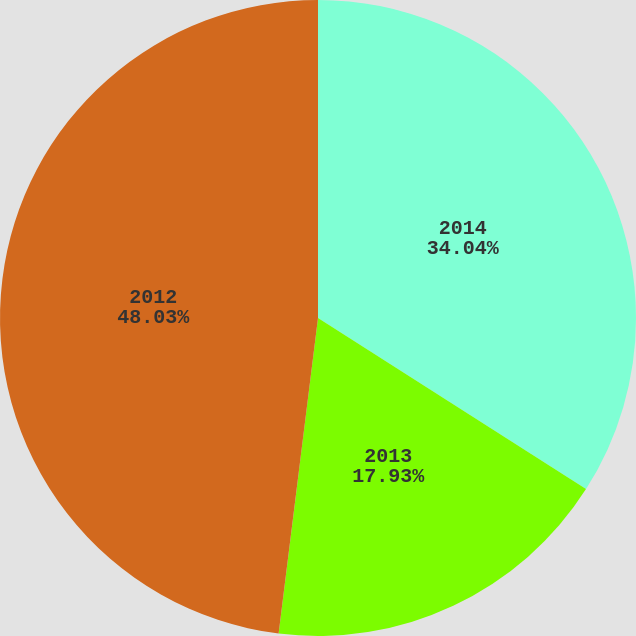Convert chart to OTSL. <chart><loc_0><loc_0><loc_500><loc_500><pie_chart><fcel>2014<fcel>2013<fcel>2012<nl><fcel>34.04%<fcel>17.93%<fcel>48.02%<nl></chart> 